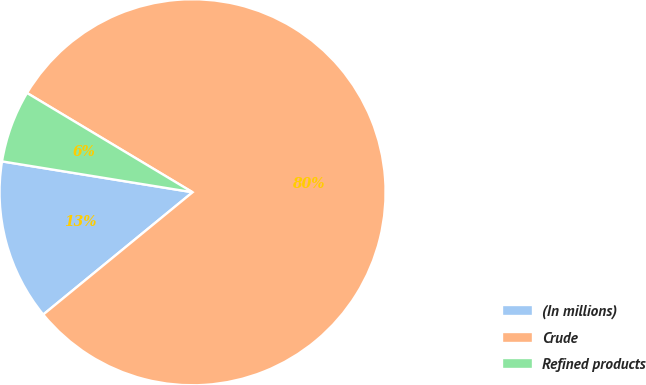<chart> <loc_0><loc_0><loc_500><loc_500><pie_chart><fcel>(In millions)<fcel>Crude<fcel>Refined products<nl><fcel>13.48%<fcel>80.48%<fcel>6.04%<nl></chart> 